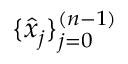Convert formula to latex. <formula><loc_0><loc_0><loc_500><loc_500>\{ \hat { x } _ { j } \} _ { j = 0 } ^ { ( n - 1 ) }</formula> 